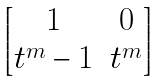<formula> <loc_0><loc_0><loc_500><loc_500>\begin{bmatrix} 1 & 0 \\ t ^ { m } - 1 & t ^ { m } \end{bmatrix}</formula> 